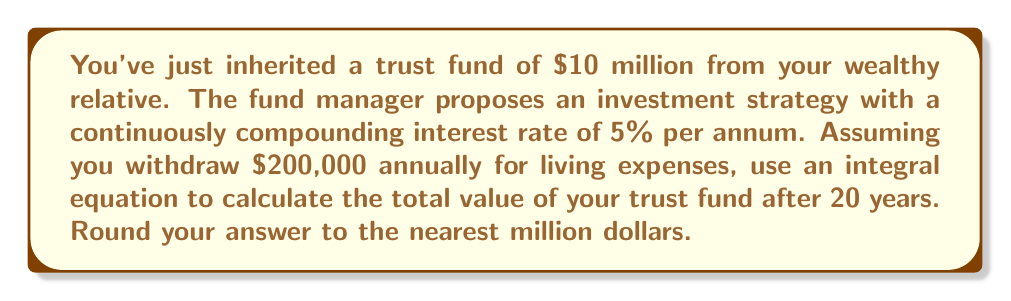Can you solve this math problem? Let's approach this step-by-step:

1) We start with the general formula for continuous compound interest with withdrawals:

   $$A(t) = P e^{rt} - \frac{w}{r}(e^{rt} - 1)$$

   Where:
   $A(t)$ is the amount after time $t$
   $P$ is the principal (initial investment)
   $r$ is the interest rate
   $w$ is the annual withdrawal
   $t$ is the time in years

2) We're given:
   $P = 10,000,000$
   $r = 0.05$ (5% expressed as a decimal)
   $w = 200,000$
   $t = 20$

3) Let's substitute these values into our equation:

   $$A(20) = 10,000,000 e^{0.05 * 20} - \frac{200,000}{0.05}(e^{0.05 * 20} - 1)$$

4) Simplify the exponents:

   $$A(20) = 10,000,000 e^1 - \frac{200,000}{0.05}(e^1 - 1)$$

5) Calculate $e^1$:

   $$A(20) = 10,000,000 * 2.71828 - \frac{200,000}{0.05}(2.71828 - 1)$$

6) Simplify:

   $$A(20) = 27,182,800 - 4,000,000 * 1.71828$$

7) Calculate:

   $$A(20) = 27,182,800 - 6,873,120 = 20,309,680$$

8) Round to the nearest million:

   $$A(20) \approx 20,000,000$$
Answer: $20 million 